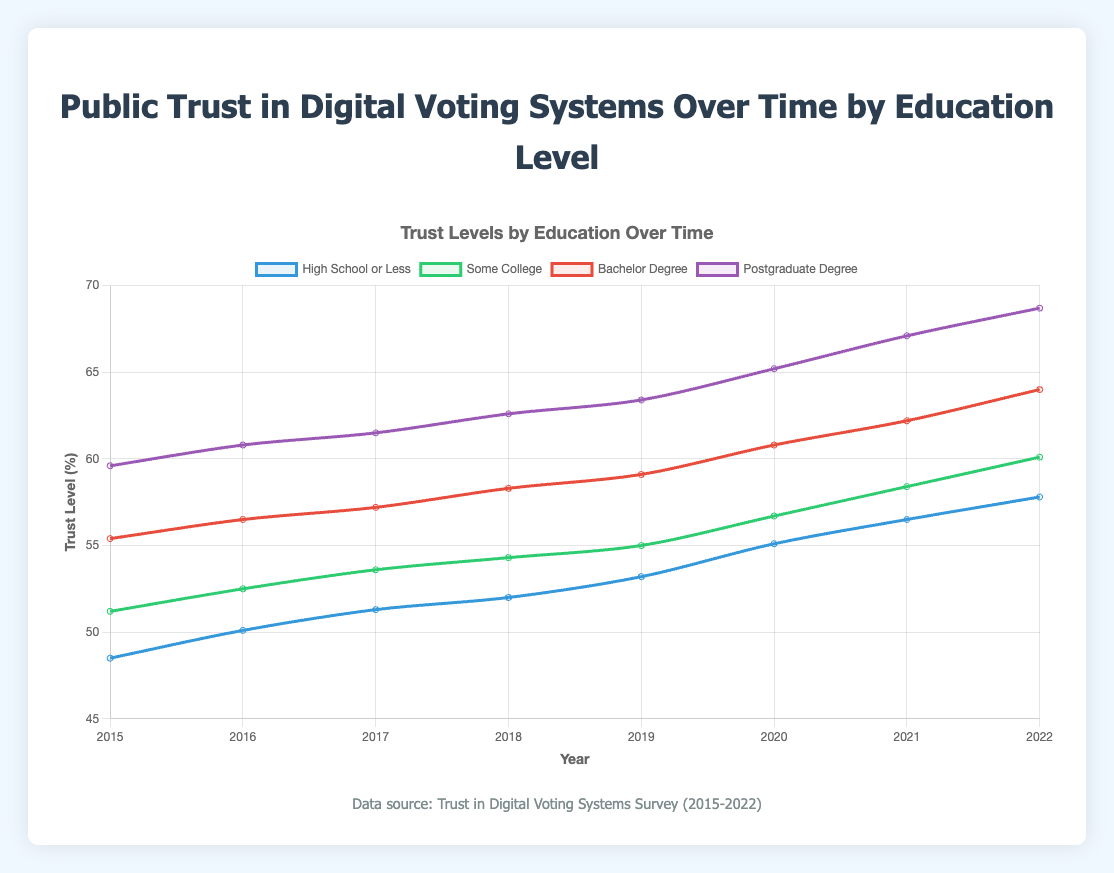What is the overall trend of trust in digital voting systems for individuals with a postgraduate degree? Trust for individuals with a postgraduate degree is increasing over time. From 59.6% in 2015, it rises steadily to 68.7% in 2022.
Answer: Increasing Which education level had the greatest increase in trust from 2015 to 2022? Calculate the change for each education level from 2015 to 2022. High School or Less: 57.8 - 48.5 = 9.3, Some College: 60.1 - 51.2 = 8.9, Bachelor's Degree: 64.0 - 55.4 = 8.6, Postgraduate Degree: 68.7 - 59.6 = 9.1. The greatest increase is for High School or Less, with an increase of 9.3.
Answer: High School or Less Did any education level experience a decline in trust over the observed period? All education levels show an upward trend from 2015 to 2022. None experienced a decline in trust.
Answer: No How does the trust level in 2022 compare for individuals with some college education versus those with a bachelor's degree? In 2022, the trust level for individuals with some college education is 60.1%, whereas for those with a bachelor's degree, it's 64.0%. Trust is higher for individuals with a bachelor’s degree.
Answer: Bachelor's degree By how many percentage points did public trust for individuals with some college education increase from 2019 to 2022? Trust in 2019 was 55.0%, and in 2022 it was 60.1%. The increase is 60.1 - 55.0 = 5.1 percentage points.
Answer: 5.1 In what year did trust for individuals with a postgraduate degree first exceed 65%? Examine the trust level for each year in the dataset. In 2020, trust for individuals with a postgraduate degree was 65.2%, the first year it exceeded 65%.
Answer: 2020 What's the average trust level across all education levels in the year 2020? The trust levels in 2020 are: High School or Less (55.1), Some College (56.7), Bachelor's Degree (60.8), Postgraduate Degree (65.2). The average is (55.1 + 56.7 + 60.8 + 65.2) / 4 = 237.8 / 4 = 59.45%.
Answer: 59.45% Which education level consistently shows the highest trust in digital voting systems? Across all years from 2015 to 2022, the data shows that individuals with a postgraduate degree have the highest trust level.
Answer: Postgraduate Degree Compare the trust levels between the 'High School or Less' and 'Some College' groups in 2017. Which group has a higher trust level? In 2017, the trust level for High School or Less is 51.3%, while for Some College, it is 53.6%. The Some College group has a higher trust level.
Answer: Some College What can be inferred about the relationship between educational attainment and trust in digital voting systems based on the trends shown? As educational attainment increases, trust in digital voting systems also increases. Higher education levels consistently show higher trust percentages over the years.
Answer: Higher education level correlates with higher trust 